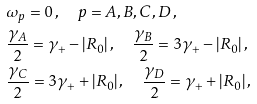Convert formula to latex. <formula><loc_0><loc_0><loc_500><loc_500>& \omega _ { p } = 0 \, , \quad p = A , B , C , D \, , \\ & \frac { \gamma _ { A } } { 2 } = \gamma _ { + } - | R _ { 0 } | \, , \quad \frac { \gamma _ { B } } { 2 } = 3 \gamma _ { + } - | R _ { 0 } | \, , \\ & \frac { \gamma _ { C } } { 2 } = 3 \gamma _ { + } + | R _ { 0 } | \, , \quad \frac { \gamma _ { D } } { 2 } = \gamma _ { + } + | R _ { 0 } | \, ,</formula> 